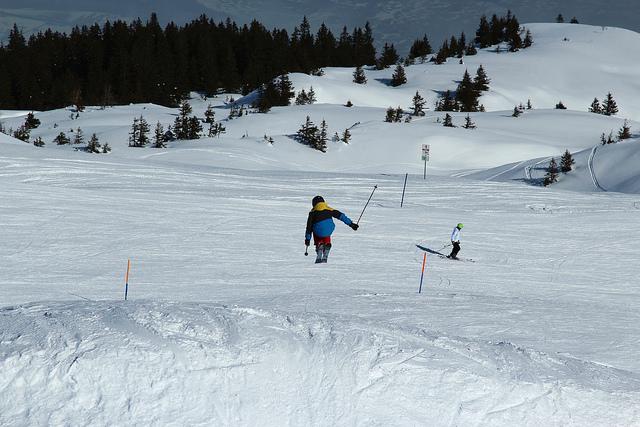Is it snowing?
Keep it brief. No. What is the man doing?
Answer briefly. Skiing. How many snowboarders in this picture?
Be succinct. 2. 